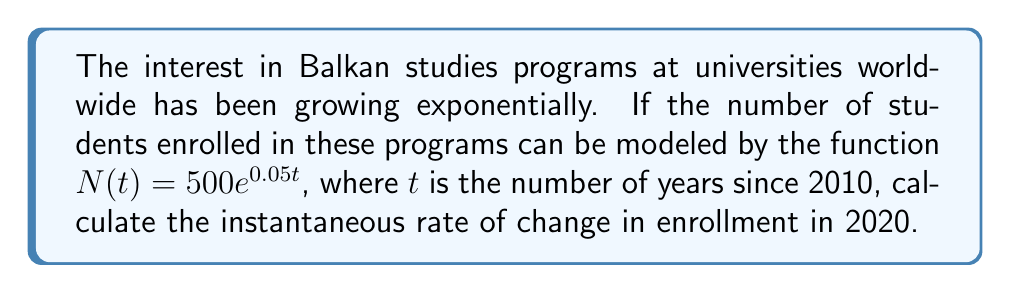Help me with this question. To solve this problem, we'll follow these steps:

1) The given function is $N(t) = 500e^{0.05t}$, where $N$ is the number of students and $t$ is time in years since 2010.

2) To find the instantaneous rate of change, we need to find the derivative of this function:

   $\frac{dN}{dt} = 500 \cdot 0.05e^{0.05t} = 25e^{0.05t}$

3) The question asks for the rate of change in 2020, which is 10 years after 2010. So we need to evaluate the derivative at $t = 10$:

   $\frac{dN}{dt}\bigg|_{t=10} = 25e^{0.05(10)} = 25e^{0.5}$

4) Calculate this value:
   
   $25e^{0.5} \approx 41.1858$

5) Interpret the result: The instantaneous rate of change in 2020 is approximately 41.1858 students per year.
Answer: 41.1858 students/year 